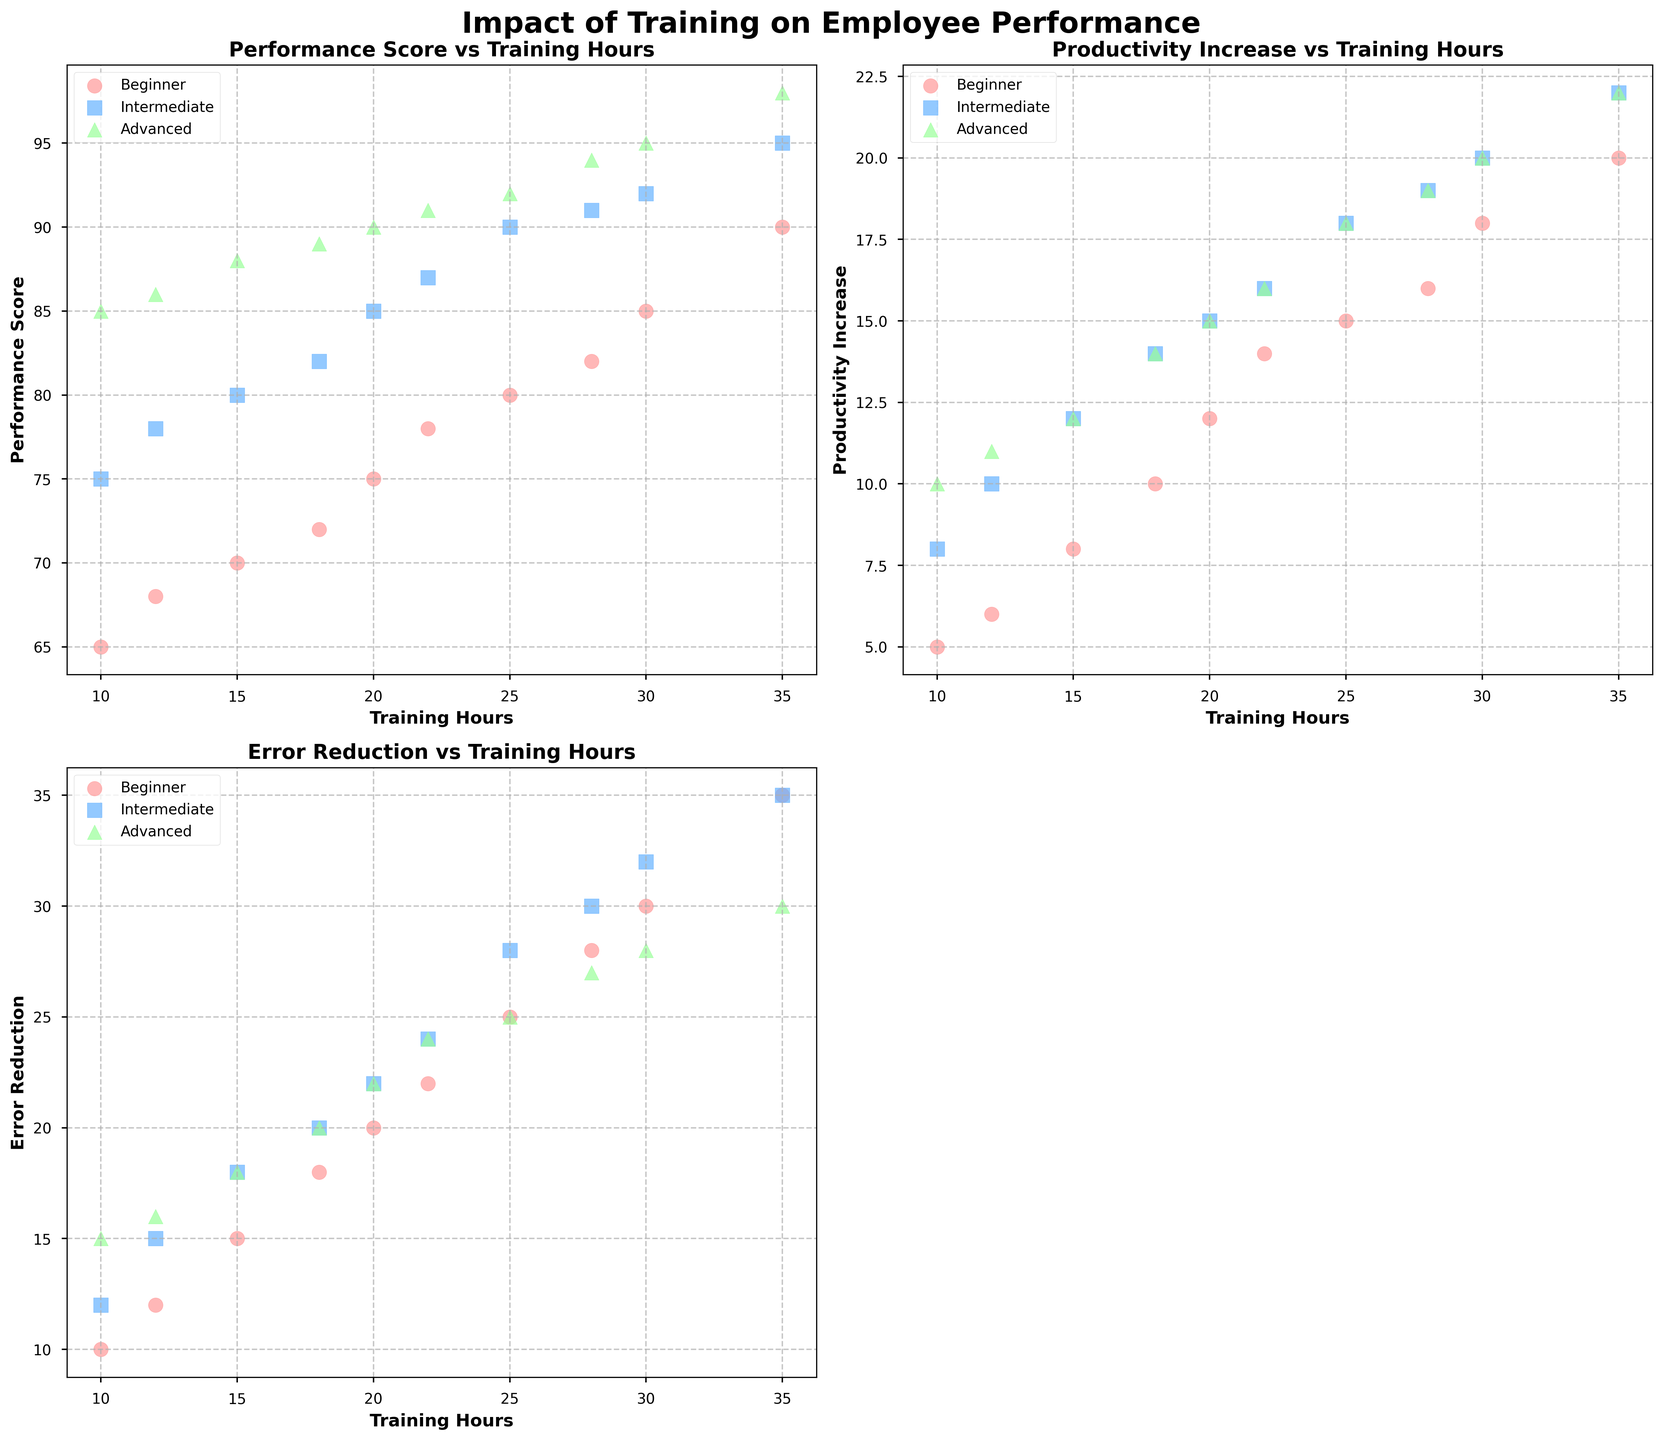How does productivity increase vary among different skill levels when training hours increase? When observing the scatter plots for productivity increase, notice the different skill levels indicated by color and marker type. Beginner-level employees (red circles) show a consistent increase in productivity with more training hours, Intermediate-level (blue squares) also show a similar trend but with generally higher productivity. Advanced-level employees (green triangles) have the highest productivity increase with the same or fewer training hours compared to the other two groups.
Answer: Advanced-level employees show the highest productivity increase with fewer training hours What is the trend in performance scores as training hours increase for each skill level? By examining the scatter plot of Performance Score vs Training Hours, locate the clusters for Beginner, Intermediate, and Advanced skill levels indicated by different colors and markers. Beginner employees show a steady increase in performance scores with increased training hours. The Intermediate group also shows an increase, but starting at a higher baseline score. Advanced employees exhibit high performance scores even with fewer training hours, and the scores increase slightly as training hours increase.
Answer: All skill levels show an increase in performance scores with training hours, starting from different baselines Which skill level shows the least variation in error reduction with varying training hours? Look at the scatter plot for Error Reduction vs Training Hours. This plot shows how error reduction varies with training hours across different skill levels. Notice the spread of data points. Beginner employees (red circles) have widely spread points, indicating larger variation. Intermediate employees (blue squares) have points that are more closely packed, signaling less variation. Advanced employees (green triangles) also have less spread, but Intermediate employees' data points are the closest.
Answer: Intermediate skill level Is there a skill level that achieves a performance score above 90 with 20 or fewer training hours? Refer to the scatter plot of Performance Score vs Training Hours and identify the data points with performance scores above 90. Check the training hours associated with these points. For Advanced-level employees (green triangles), observe that there are scores above 90 even with training at or below 20 hours. For Beginners and Intermediates, scores exceeding 90 require more than 20 hours of training.
Answer: Yes, Advanced skill level Which skill level benefits the most in terms of productivity increase with additional training hours? Observe the slope or trend lines visually created by the scatter plot for Productivity Increase vs Training Hours. Determine which skill level has the steeper or noticeable upward trend. For Beginners (red circles), the slope is less steep compared to Intermediate (blue squares) and Advanced employees (green triangles). The Advanced skill level demonstrates the most substantial increase with an upward trend even with relatively fewer training hours.
Answer: Advanced skill level Between Beginner and Intermediate skill levels, which group sees a larger increase in error reduction with more training hours? Examine the Error Reduction vs Training Hours scatter plot for Beginners (red circles) and Intermediates (blue squares). Notice the trend and the spread. Beginners show increased error reduction as training hours increase, but Intermediates display a more substantial and more consistent increase in error reduction, with closely packed points indicating a steady trend.
Answer: Intermediate skill level 